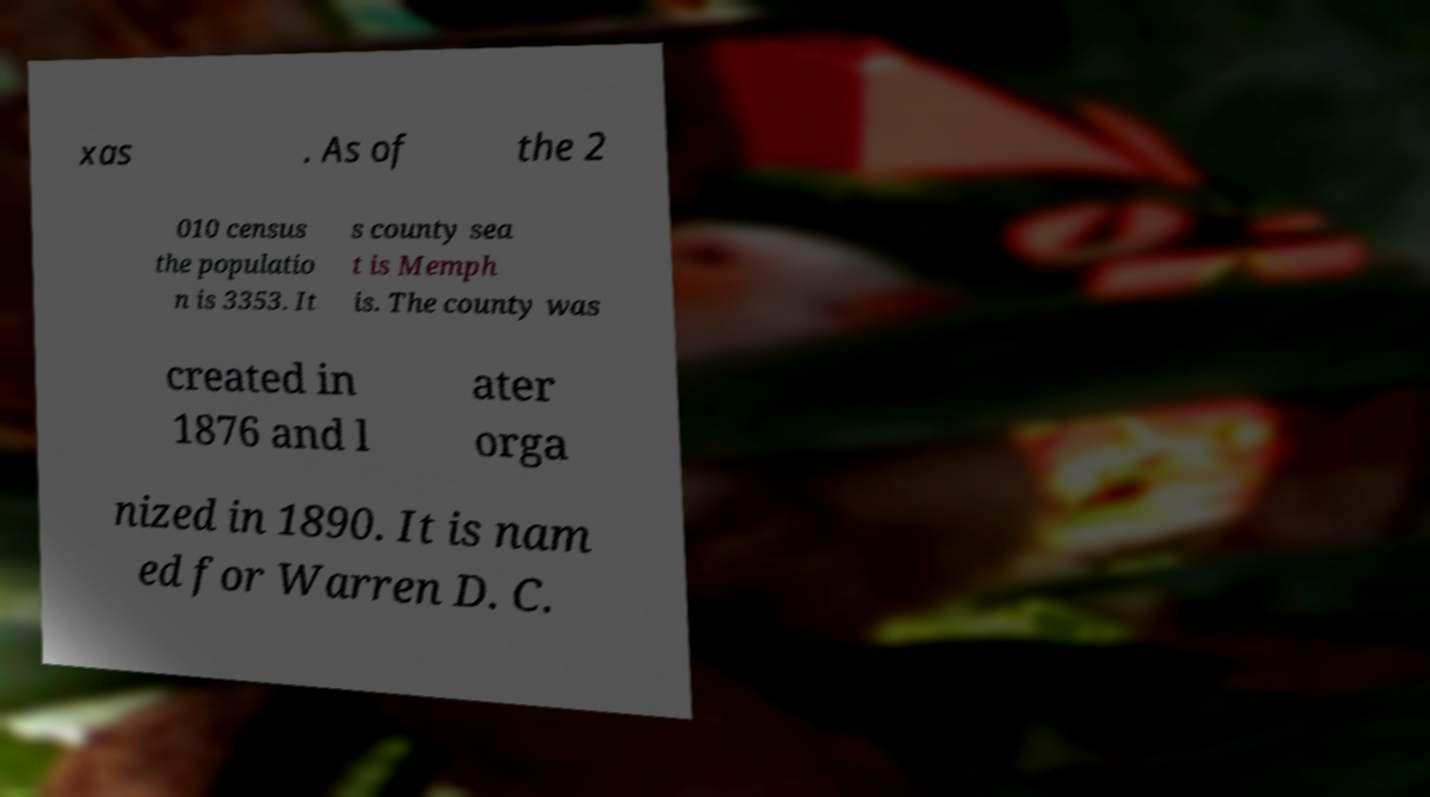Can you read and provide the text displayed in the image?This photo seems to have some interesting text. Can you extract and type it out for me? xas . As of the 2 010 census the populatio n is 3353. It s county sea t is Memph is. The county was created in 1876 and l ater orga nized in 1890. It is nam ed for Warren D. C. 